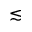<formula> <loc_0><loc_0><loc_500><loc_500>\lesssim</formula> 